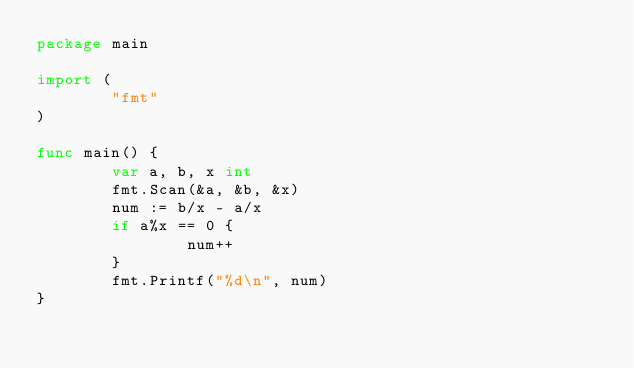<code> <loc_0><loc_0><loc_500><loc_500><_Go_>package main

import (
        "fmt"
)

func main() {
        var a, b, x int
        fmt.Scan(&a, &b, &x)
        num := b/x - a/x
        if a%x == 0 {
                num++
        }
        fmt.Printf("%d\n", num)
}</code> 